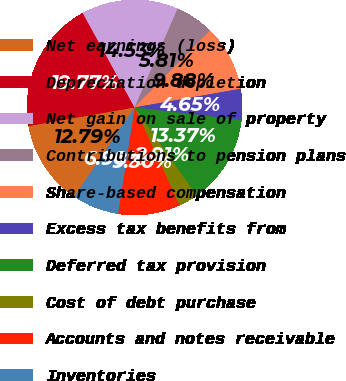Convert chart. <chart><loc_0><loc_0><loc_500><loc_500><pie_chart><fcel>Net earnings (loss)<fcel>Depreciation depletion<fcel>Net gain on sale of property<fcel>Contributions to pension plans<fcel>Share-based compensation<fcel>Excess tax benefits from<fcel>Deferred tax provision<fcel>Cost of debt purchase<fcel>Accounts and notes receivable<fcel>Inventories<nl><fcel>12.79%<fcel>19.77%<fcel>14.53%<fcel>5.81%<fcel>9.88%<fcel>4.65%<fcel>13.37%<fcel>2.91%<fcel>9.3%<fcel>6.98%<nl></chart> 